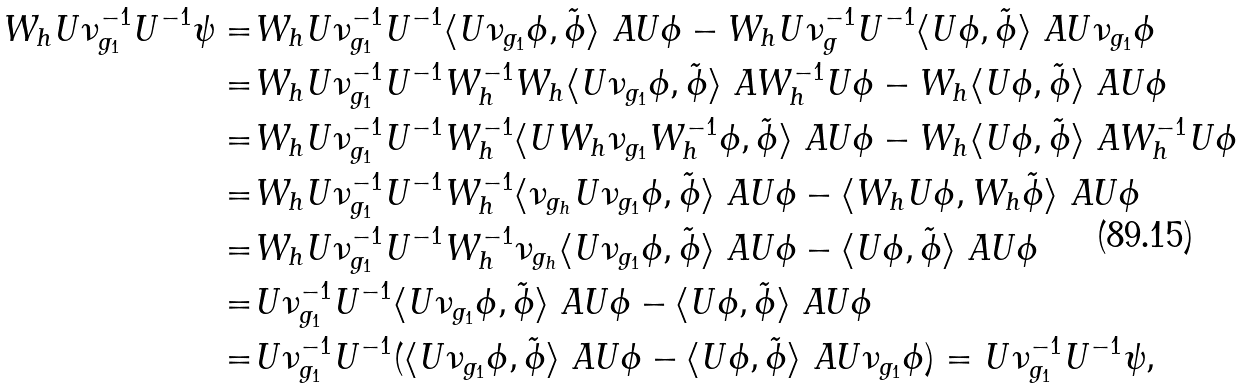Convert formula to latex. <formula><loc_0><loc_0><loc_500><loc_500>W _ { h } U \nu _ { g _ { 1 } } ^ { - 1 } U ^ { - 1 } \psi = & W _ { h } U \nu _ { g _ { 1 } } ^ { - 1 } U ^ { - 1 } \langle U \nu _ { g _ { 1 } } \phi , \tilde { \phi } \rangle _ { \ } A U \phi - W _ { h } U \nu _ { g } ^ { - 1 } U ^ { - 1 } \langle U \phi , \tilde { \phi } \rangle _ { \ } A U \nu _ { g _ { 1 } } \phi \\ = & W _ { h } U \nu _ { g _ { 1 } } ^ { - 1 } U ^ { - 1 } W _ { h } ^ { - 1 } W _ { h } \langle U \nu _ { g _ { 1 } } \phi , \tilde { \phi } \rangle _ { \ } A W _ { h } ^ { - 1 } U \phi - W _ { h } \langle U \phi , \tilde { \phi } \rangle _ { \ } A U \phi \\ = & W _ { h } U \nu _ { g _ { 1 } } ^ { - 1 } U ^ { - 1 } W _ { h } ^ { - 1 } \langle U W _ { h } \nu _ { g _ { 1 } } W _ { h } ^ { - 1 } \phi , \tilde { \phi } \rangle _ { \ } A U \phi - W _ { h } \langle U \phi , \tilde { \phi } \rangle _ { \ } A W _ { h } ^ { - 1 } U \phi \\ = & W _ { h } U \nu _ { g _ { 1 } } ^ { - 1 } U ^ { - 1 } W _ { h } ^ { - 1 } \langle \nu _ { g _ { h } } U \nu _ { g _ { 1 } } \phi , \tilde { \phi } \rangle _ { \ } A U \phi - \langle W _ { h } U \phi , W _ { h } \tilde { \phi } \rangle _ { \ } A U \phi \\ = & W _ { h } U \nu _ { g _ { 1 } } ^ { - 1 } U ^ { - 1 } W _ { h } ^ { - 1 } \nu _ { g _ { h } } \langle U \nu _ { g _ { 1 } } \phi , \tilde { \phi } \rangle _ { \ } A U \phi - \langle U \phi , \tilde { \phi } \rangle _ { \ } A U \phi \\ = & U \nu _ { g _ { 1 } } ^ { - 1 } U ^ { - 1 } \langle U \nu _ { g _ { 1 } } \phi , \tilde { \phi } \rangle _ { \ } A U \phi - \langle U \phi , \tilde { \phi } \rangle _ { \ } A U \phi \\ = & U \nu _ { g _ { 1 } } ^ { - 1 } U ^ { - 1 } ( \langle U \nu _ { g _ { 1 } } \phi , \tilde { \phi } \rangle _ { \ } A U \phi - \langle U \phi , \tilde { \phi } \rangle _ { \ } A U \nu _ { g _ { 1 } } \phi ) = U \nu _ { g _ { 1 } } ^ { - 1 } U ^ { - 1 } \psi ,</formula> 